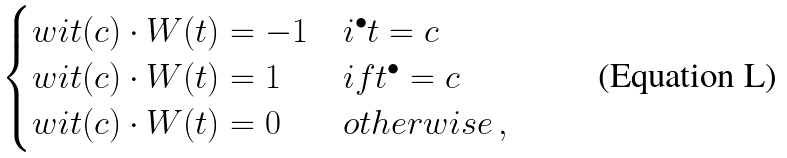Convert formula to latex. <formula><loc_0><loc_0><loc_500><loc_500>\begin{cases} w i t ( c ) \cdot W ( t ) = - 1 & i ^ { \bullet } t = c \\ w i t ( c ) \cdot W ( t ) = 1 & i f t ^ { \bullet } = c \\ w i t ( c ) \cdot W ( t ) = 0 & o t h e r w i s e \, , \end{cases}</formula> 